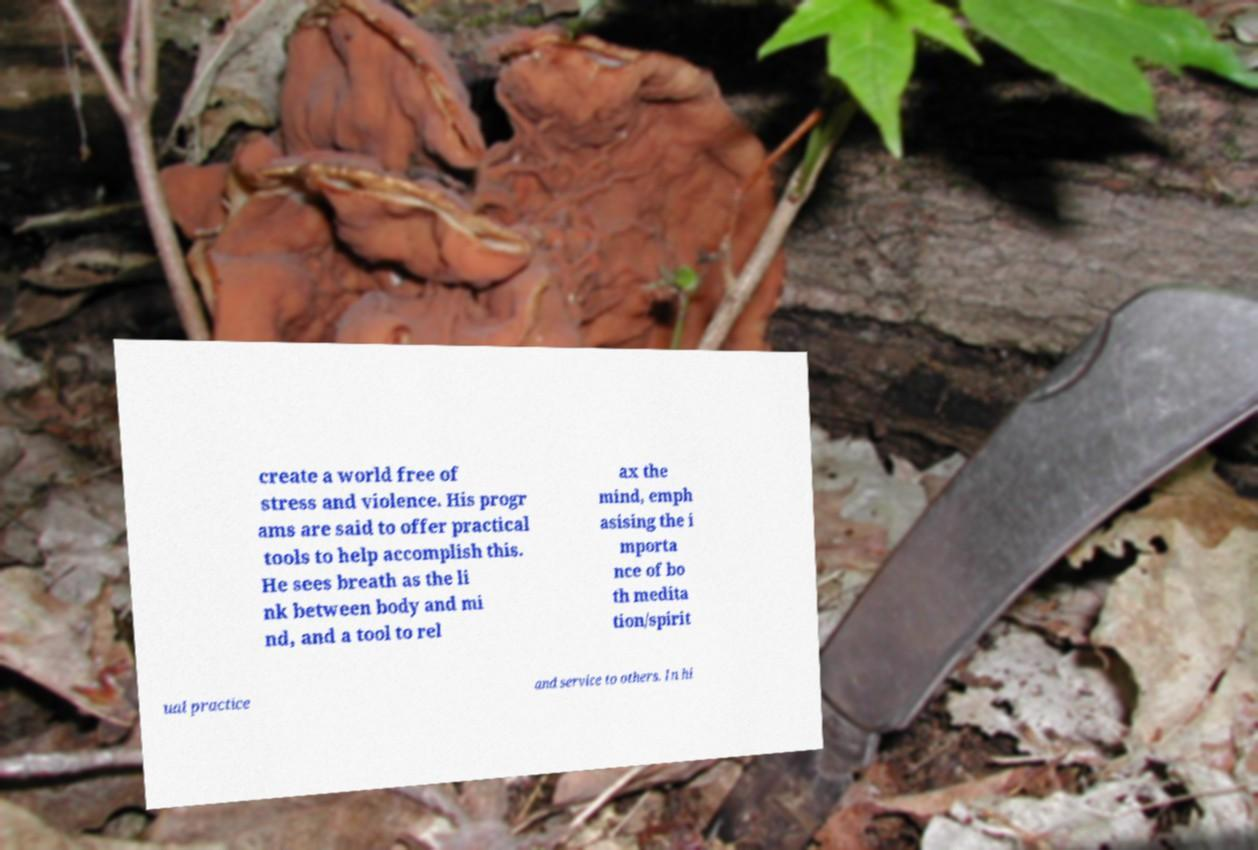For documentation purposes, I need the text within this image transcribed. Could you provide that? create a world free of stress and violence. His progr ams are said to offer practical tools to help accomplish this. He sees breath as the li nk between body and mi nd, and a tool to rel ax the mind, emph asising the i mporta nce of bo th medita tion/spirit ual practice and service to others. In hi 